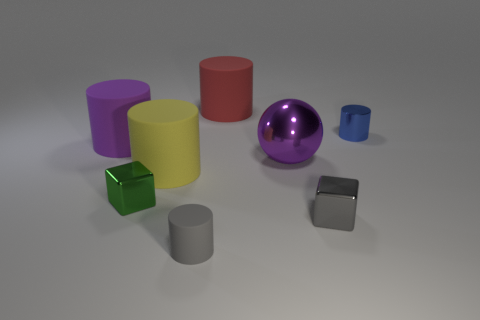Subtract all cyan cylinders. Subtract all yellow blocks. How many cylinders are left? 5 Add 1 tiny gray objects. How many objects exist? 9 Subtract all cylinders. How many objects are left? 3 Subtract 1 green cubes. How many objects are left? 7 Subtract all big brown spheres. Subtract all metallic cylinders. How many objects are left? 7 Add 7 blue cylinders. How many blue cylinders are left? 8 Add 2 gray things. How many gray things exist? 4 